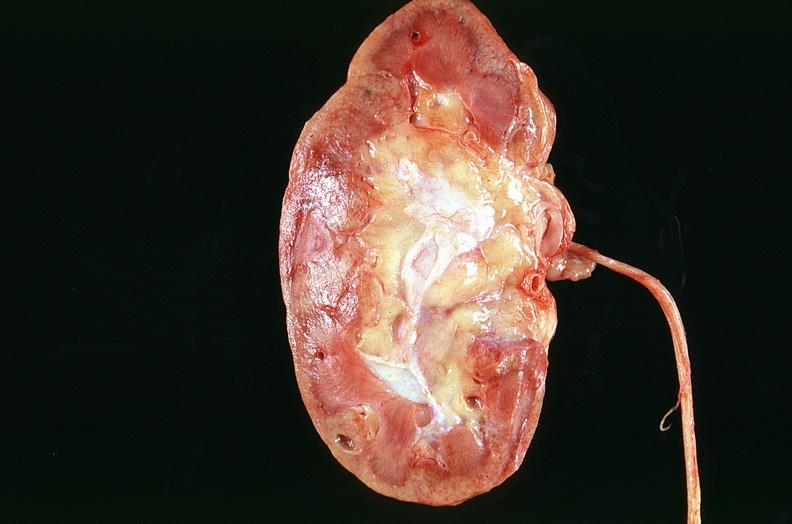what does this image show?
Answer the question using a single word or phrase. Kidney 